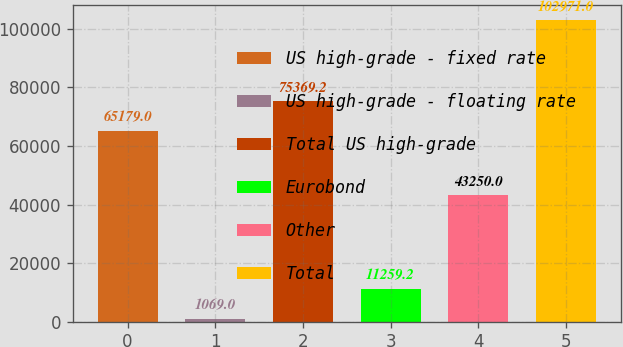Convert chart. <chart><loc_0><loc_0><loc_500><loc_500><bar_chart><fcel>US high-grade - fixed rate<fcel>US high-grade - floating rate<fcel>Total US high-grade<fcel>Eurobond<fcel>Other<fcel>Total<nl><fcel>65179<fcel>1069<fcel>75369.2<fcel>11259.2<fcel>43250<fcel>102971<nl></chart> 